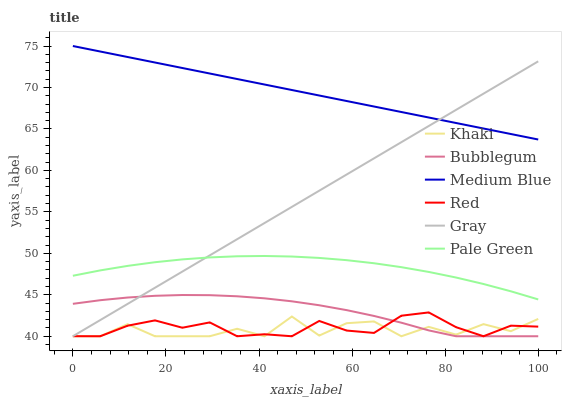Does Khaki have the minimum area under the curve?
Answer yes or no. Yes. Does Medium Blue have the maximum area under the curve?
Answer yes or no. Yes. Does Medium Blue have the minimum area under the curve?
Answer yes or no. No. Does Khaki have the maximum area under the curve?
Answer yes or no. No. Is Medium Blue the smoothest?
Answer yes or no. Yes. Is Khaki the roughest?
Answer yes or no. Yes. Is Khaki the smoothest?
Answer yes or no. No. Is Medium Blue the roughest?
Answer yes or no. No. Does Gray have the lowest value?
Answer yes or no. Yes. Does Medium Blue have the lowest value?
Answer yes or no. No. Does Medium Blue have the highest value?
Answer yes or no. Yes. Does Khaki have the highest value?
Answer yes or no. No. Is Pale Green less than Medium Blue?
Answer yes or no. Yes. Is Pale Green greater than Bubblegum?
Answer yes or no. Yes. Does Red intersect Khaki?
Answer yes or no. Yes. Is Red less than Khaki?
Answer yes or no. No. Is Red greater than Khaki?
Answer yes or no. No. Does Pale Green intersect Medium Blue?
Answer yes or no. No. 